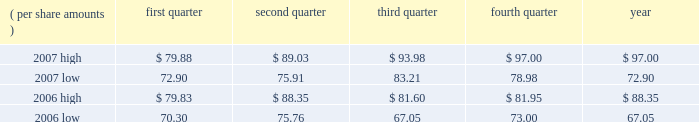Item 1b .
Unresolved staff comments .
Item 2 .
Properties .
3m 2019s general offices , corporate research laboratories , and certain division laboratories are located in st .
Paul , minnesota .
In the united states , 3m has nine sales offices in eight states and operates 74 manufacturing facilities in 27 states .
Internationally , 3m has 148 sales offices .
The company operates 93 manufacturing and converting facilities in 32 countries outside the united states .
3m owns substantially all of its physical properties .
3m 2019s physical facilities are highly suitable for the purposes for which they were designed .
Because 3m is a global enterprise characterized by substantial intersegment cooperation , properties are often used by multiple business segments .
Item 3 .
Legal proceedings .
Discussion of legal matters is incorporated by reference from part ii , item 8 , note 13 , 201ccommitments and contingencies , 201d of this document , and should be considered an integral part of part i , item 3 , 201clegal proceedings . 201d item 4 .
Submission of matters to a vote of security holders .
None in the quarter ended december 31 , 2007 .
Part ii item 5 .
Market for registrant 2019s common equity , related stockholder matters and issuer purchases of equity securities .
Equity compensation plans 2019 information is incorporated by reference from part iii , item 12 , 201csecurity ownership of certain beneficial owners and management and related stockholder matters , 201d of this document , and should be considered an integral part of item 5 .
At january 31 , 2008 , there were approximately 121302 shareholders of record .
3m 2019s stock is listed on the new york stock exchange , inc .
( nyse ) , the chicago stock exchange , inc. , and the swx swiss exchange .
Cash dividends declared and paid totaled $ .48 per share for each quarter of 2007 , and $ .46 per share for each quarter of 2006 .
Stock price comparisons follow : stock price comparisons ( nyse composite transactions ) ( per share amounts ) quarter second quarter quarter fourth quarter year .
Issuer purchases of equity securities repurchases of common stock are made to support the company 2019s stock-based employee compensation plans and for other corporate purposes .
On february 13 , 2006 , the board of directors authorized the purchase of $ 2.0 billion of the company 2019s common stock between february 13 , 2006 and february 28 , 2007 .
In august 2006 , 3m 2019s board of directors authorized the repurchase of an additional $ 1.0 billion in share repurchases , raising the total authorization to $ 3.0 billion for the period from february 13 , 2006 to february 28 , 2007 .
In february 2007 , 3m 2019s board of directors authorized a two- year share repurchase of up to $ 7.0 billion for the period from february 12 , 2007 to february 28 , 2009. .
In 2006 what was the total amount authorized by the board of directors authorized for the repurchase of shares in billions? 
Rationale: the total amount authorized by the board of directors for the repurchase of shares in billions was 3 billion in 2006
Computations: (2 + 1)
Answer: 3.0. 